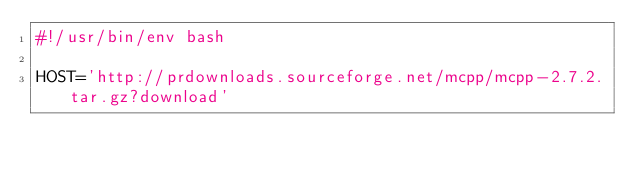<code> <loc_0><loc_0><loc_500><loc_500><_Bash_>#!/usr/bin/env bash

HOST='http://prdownloads.sourceforge.net/mcpp/mcpp-2.7.2.tar.gz?download'</code> 